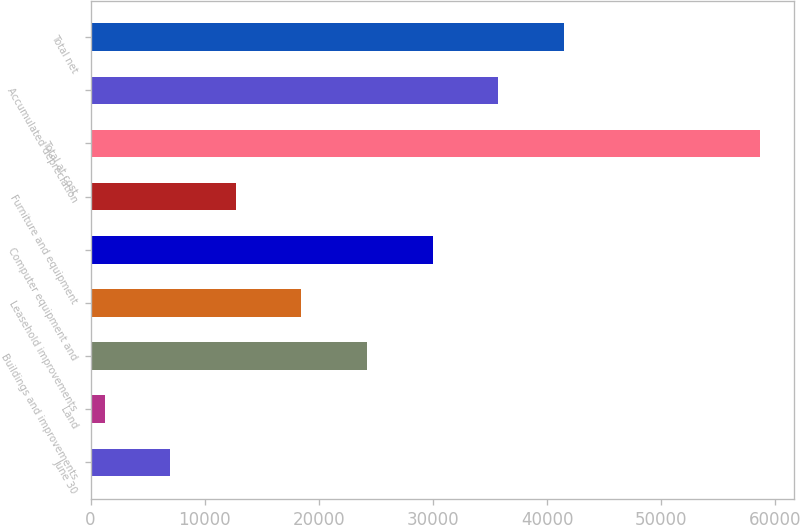Convert chart. <chart><loc_0><loc_0><loc_500><loc_500><bar_chart><fcel>June 30<fcel>Land<fcel>Buildings and improvements<fcel>Leasehold improvements<fcel>Computer equipment and<fcel>Furniture and equipment<fcel>Total at cost<fcel>Accumulated depreciation<fcel>Total net<nl><fcel>6996.9<fcel>1254<fcel>24225.6<fcel>18482.7<fcel>29968.5<fcel>12739.8<fcel>58683<fcel>35711.4<fcel>41454.3<nl></chart> 